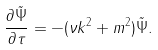Convert formula to latex. <formula><loc_0><loc_0><loc_500><loc_500>\frac { \partial { \tilde { \Psi } } } { \partial \tau } = - ( \nu k ^ { 2 } + m ^ { 2 } ) { \tilde { \Psi } } .</formula> 